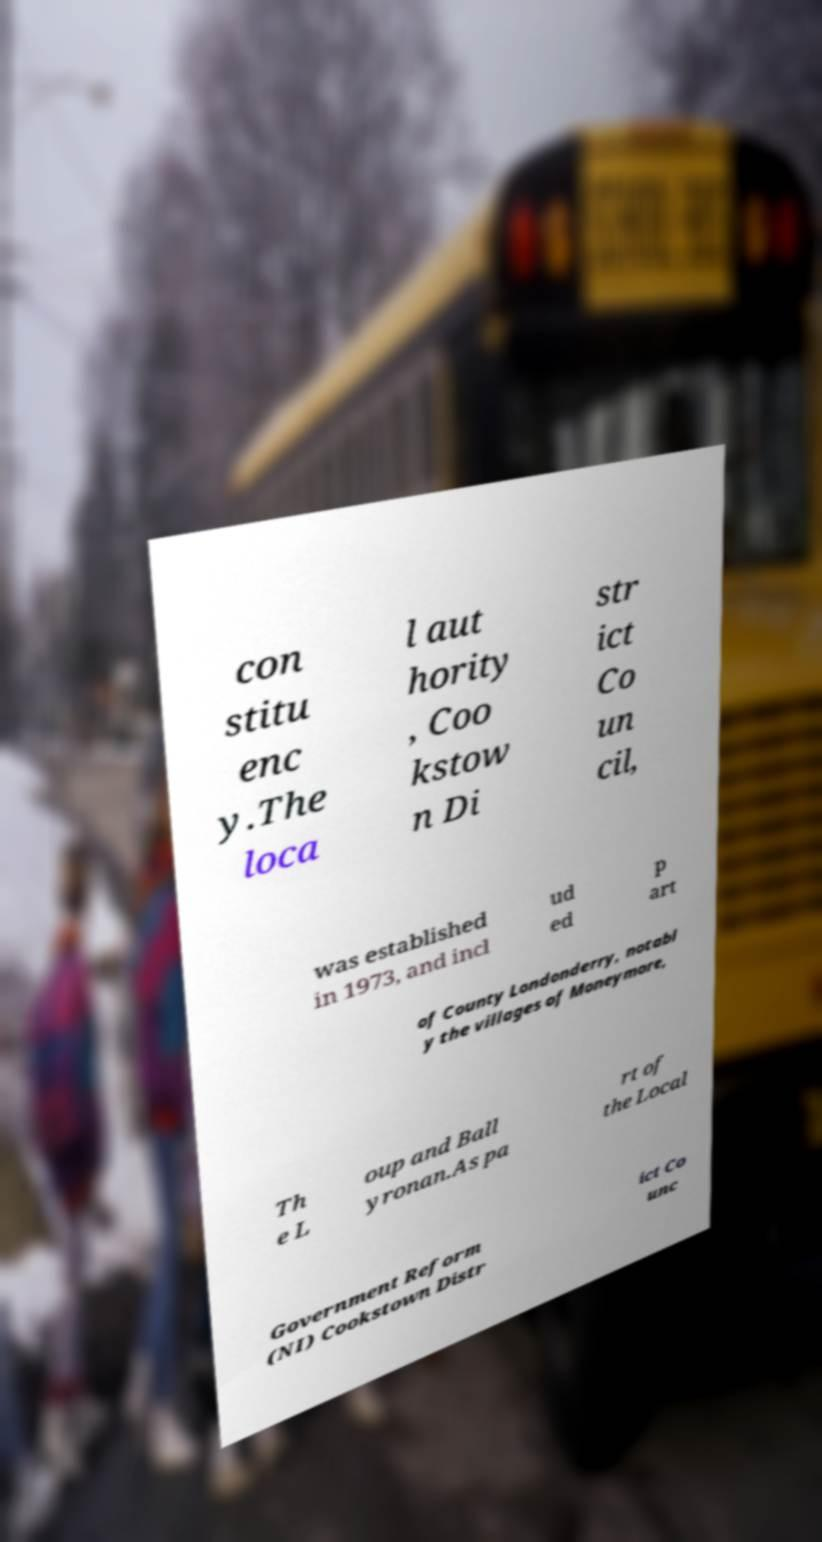I need the written content from this picture converted into text. Can you do that? con stitu enc y.The loca l aut hority , Coo kstow n Di str ict Co un cil, was established in 1973, and incl ud ed p art of County Londonderry, notabl y the villages of Moneymore, Th e L oup and Ball yronan.As pa rt of the Local Government Reform (NI) Cookstown Distr ict Co unc 